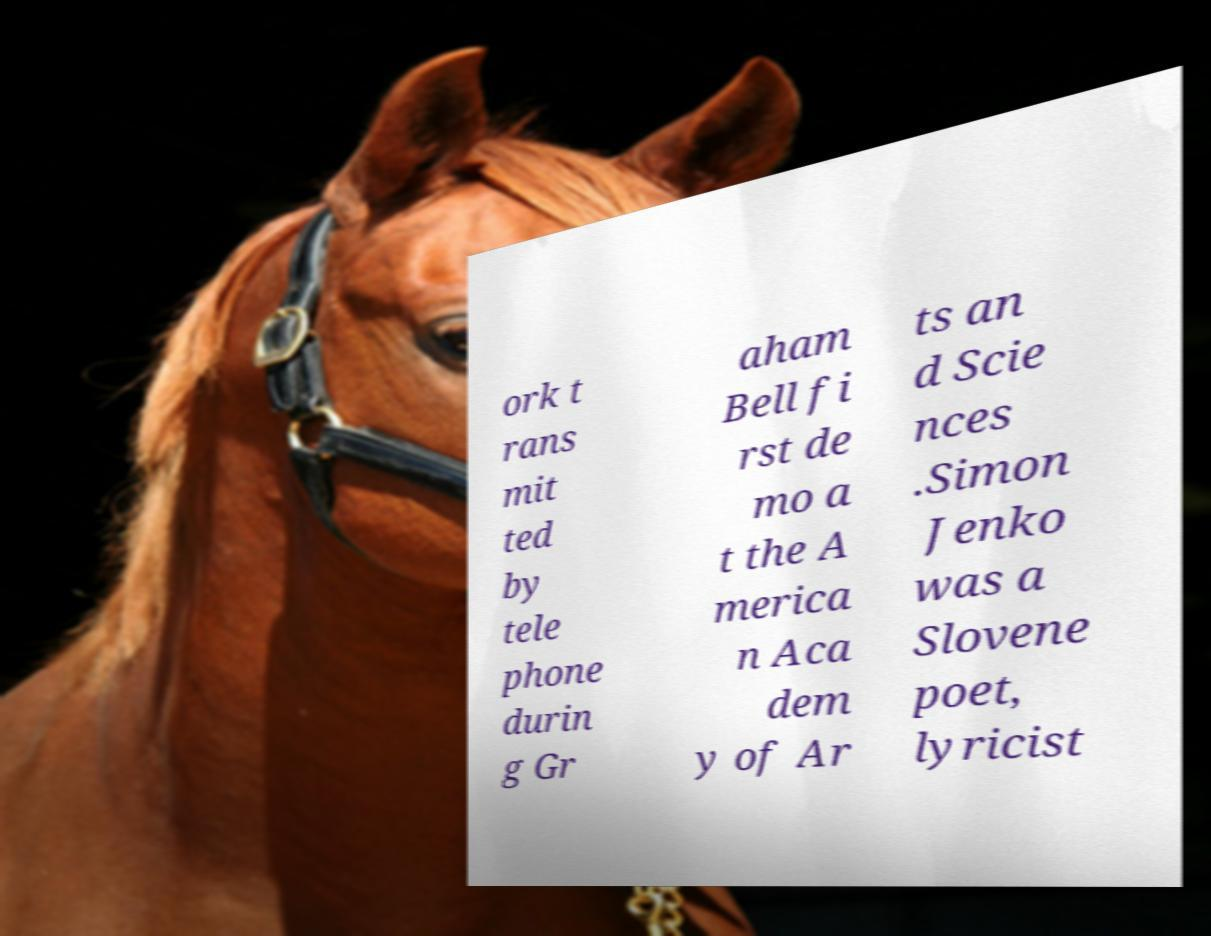There's text embedded in this image that I need extracted. Can you transcribe it verbatim? ork t rans mit ted by tele phone durin g Gr aham Bell fi rst de mo a t the A merica n Aca dem y of Ar ts an d Scie nces .Simon Jenko was a Slovene poet, lyricist 